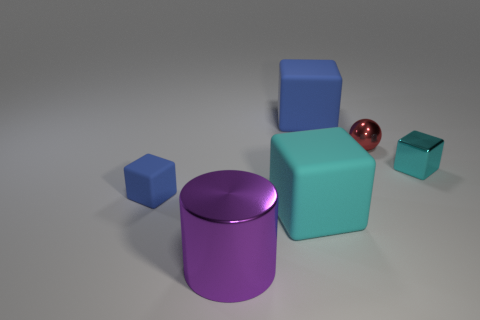Add 4 tiny brown spheres. How many objects exist? 10 Subtract all cylinders. How many objects are left? 5 Subtract all tiny red balls. Subtract all purple cylinders. How many objects are left? 4 Add 4 large rubber things. How many large rubber things are left? 6 Add 1 purple shiny things. How many purple shiny things exist? 2 Subtract 1 purple cylinders. How many objects are left? 5 